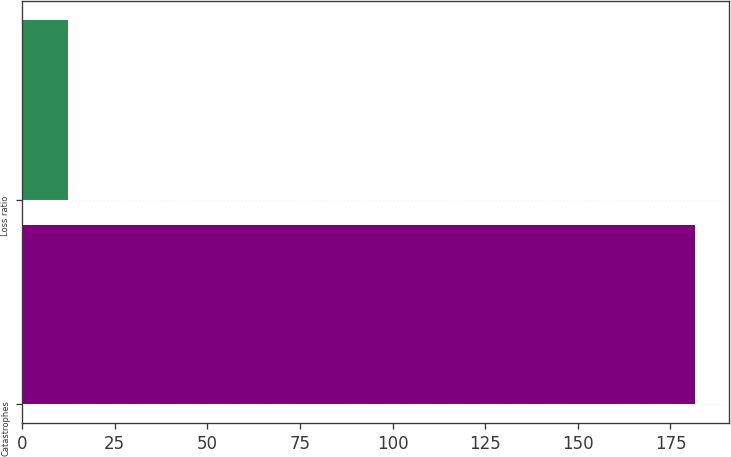Convert chart. <chart><loc_0><loc_0><loc_500><loc_500><bar_chart><fcel>Catastrophes<fcel>Loss ratio<nl><fcel>181.7<fcel>12.4<nl></chart> 